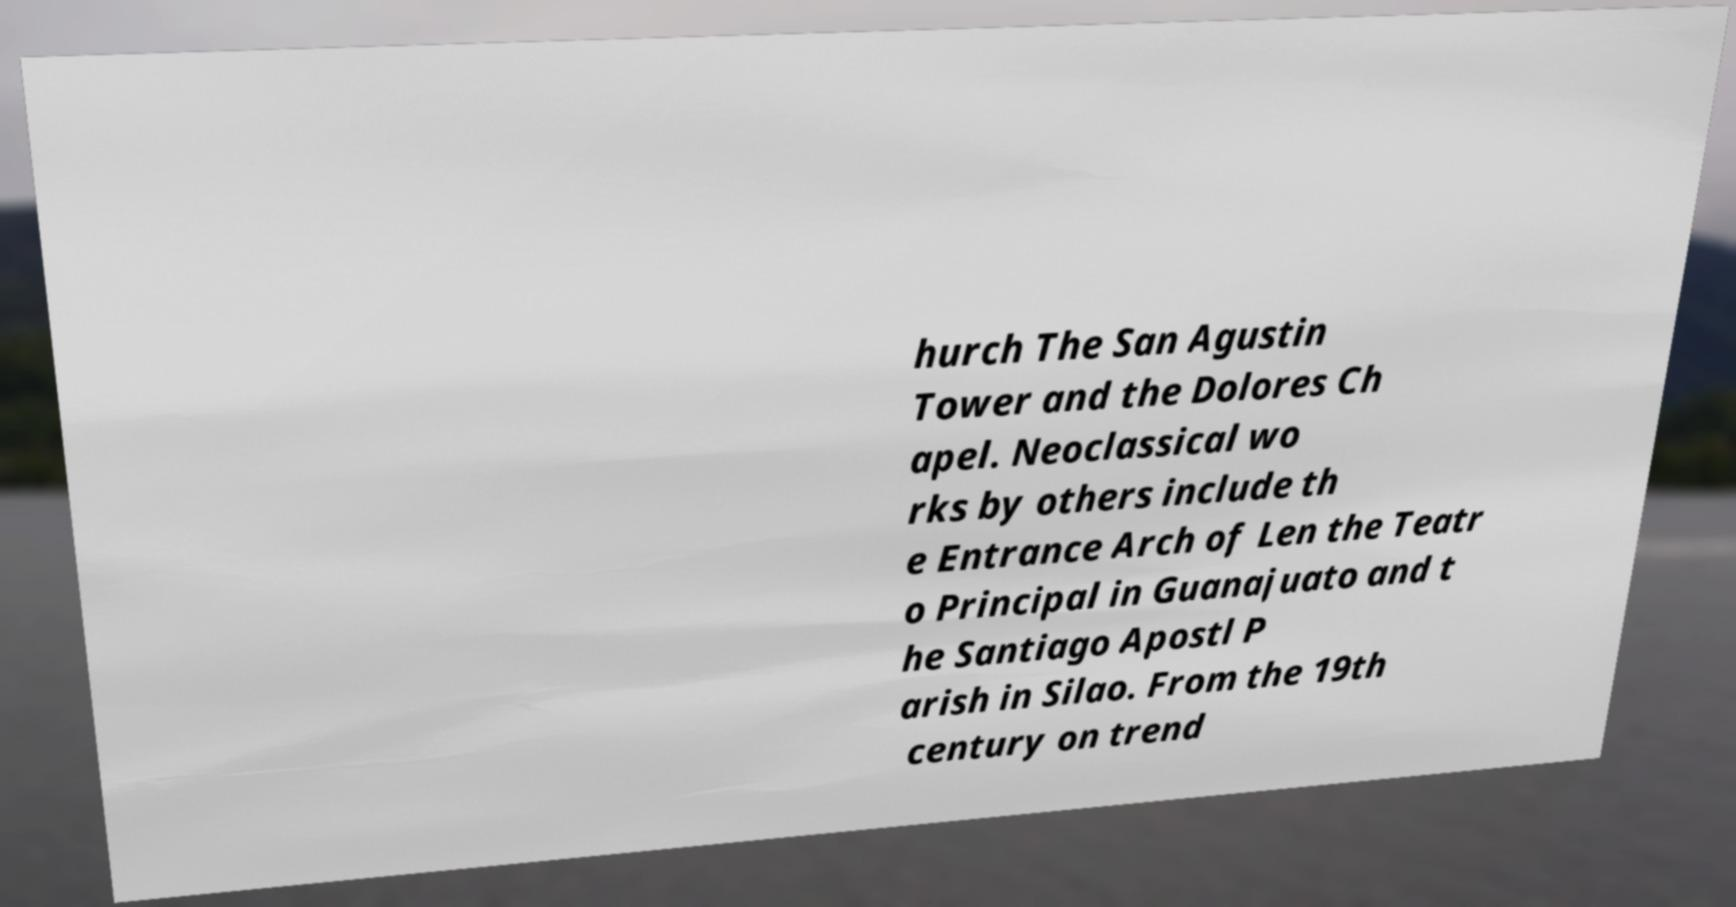What messages or text are displayed in this image? I need them in a readable, typed format. hurch The San Agustin Tower and the Dolores Ch apel. Neoclassical wo rks by others include th e Entrance Arch of Len the Teatr o Principal in Guanajuato and t he Santiago Apostl P arish in Silao. From the 19th century on trend 